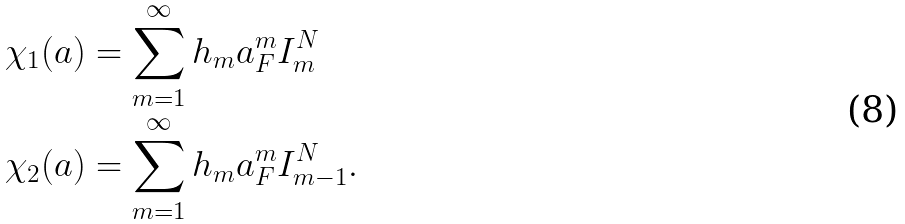<formula> <loc_0><loc_0><loc_500><loc_500>\chi _ { 1 } ( a ) & = \sum _ { m = 1 } ^ { \infty } h _ { m } a _ { F } ^ { m } I _ { m } ^ { N } \\ \chi _ { 2 } ( a ) & = \sum _ { m = 1 } ^ { \infty } h _ { m } a _ { F } ^ { m } I _ { m - 1 } ^ { N } .</formula> 